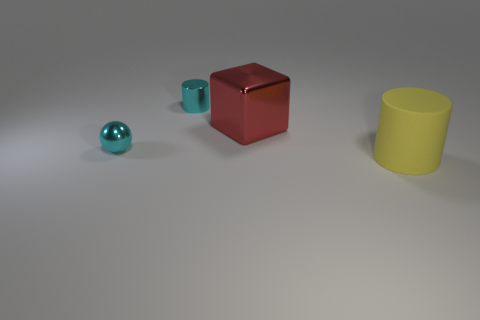Subtract all yellow cylinders. How many cylinders are left? 1 Subtract 1 balls. How many balls are left? 0 Add 4 tiny gray shiny blocks. How many objects exist? 8 Subtract all blue balls. Subtract all blue cubes. How many balls are left? 1 Subtract all purple cylinders. How many red balls are left? 0 Subtract all tiny metal things. Subtract all large matte things. How many objects are left? 1 Add 2 large yellow matte objects. How many large yellow matte objects are left? 3 Add 4 yellow rubber cylinders. How many yellow rubber cylinders exist? 5 Subtract 1 red blocks. How many objects are left? 3 Subtract all blocks. How many objects are left? 3 